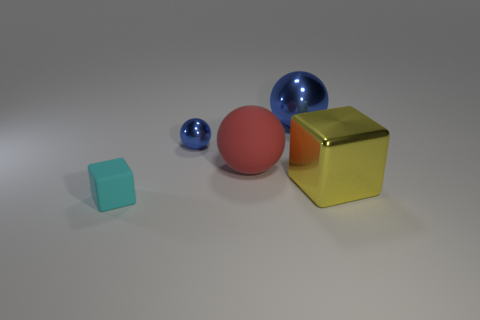Subtract 1 cubes. How many cubes are left? 1 Subtract all red balls. How many balls are left? 2 Add 4 rubber blocks. How many objects exist? 9 Subtract all yellow cubes. How many cubes are left? 1 Subtract 0 blue cylinders. How many objects are left? 5 Subtract all blocks. How many objects are left? 3 Subtract all brown balls. Subtract all cyan cubes. How many balls are left? 3 Subtract all red spheres. How many gray cubes are left? 0 Subtract all big gray objects. Subtract all blue shiny spheres. How many objects are left? 3 Add 5 small metal things. How many small metal things are left? 6 